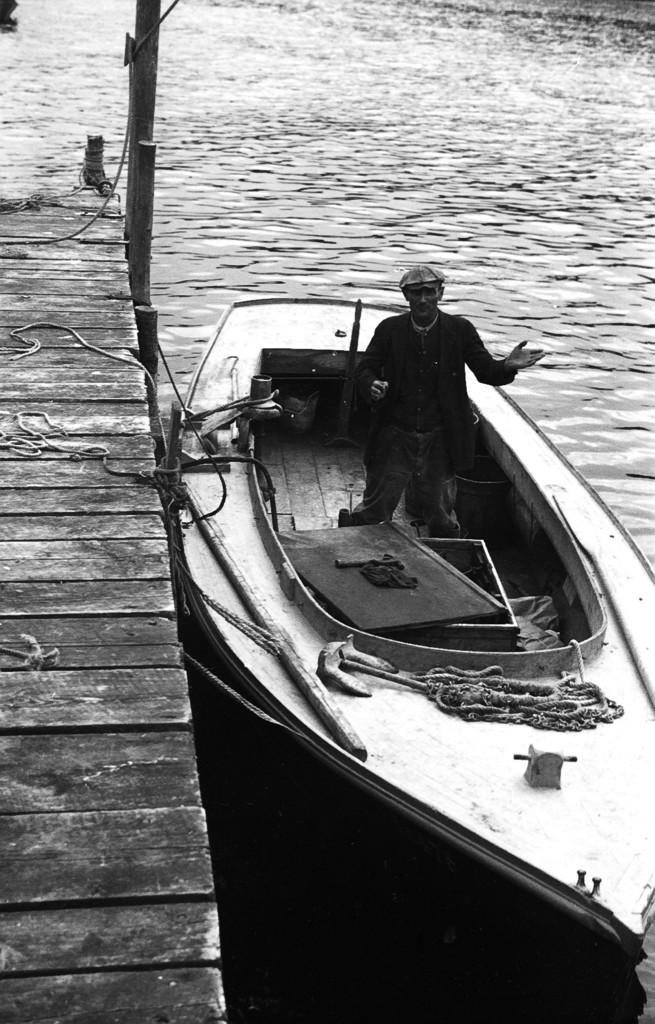What can be seen in the image? There are objects in the image, including a person standing in a boat. Where is the boat located? The boat is on the water surface. What else can be seen in the image? There is a wooden path and wooden logs present in the image. Are there any other items visible in the image? Yes, ropes are present in the image. What type of ice can be seen melting on the person's face in the image? There is no ice present in the image, and therefore no ice can be seen melting on anyone's face. 